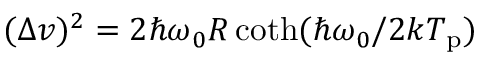Convert formula to latex. <formula><loc_0><loc_0><loc_500><loc_500>( \Delta v ) ^ { 2 } = 2 \hbar { \omega } _ { 0 } R \coth ( \hbar { \omega } _ { 0 } / 2 k T _ { p } )</formula> 